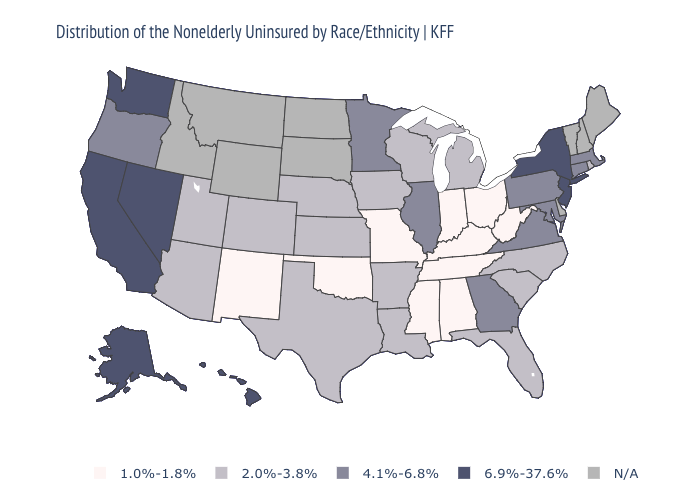Does Tennessee have the lowest value in the USA?
Write a very short answer. Yes. What is the highest value in the USA?
Quick response, please. 6.9%-37.6%. Among the states that border Nevada , which have the lowest value?
Answer briefly. Arizona, Utah. Which states have the lowest value in the USA?
Concise answer only. Alabama, Indiana, Kentucky, Mississippi, Missouri, New Mexico, Ohio, Oklahoma, Tennessee, West Virginia. What is the lowest value in the West?
Keep it brief. 1.0%-1.8%. What is the value of New Jersey?
Quick response, please. 6.9%-37.6%. Name the states that have a value in the range 4.1%-6.8%?
Quick response, please. Connecticut, Georgia, Illinois, Maryland, Massachusetts, Minnesota, Oregon, Pennsylvania, Virginia. What is the lowest value in the West?
Keep it brief. 1.0%-1.8%. Does the map have missing data?
Short answer required. Yes. What is the lowest value in the USA?
Quick response, please. 1.0%-1.8%. What is the highest value in the Northeast ?
Write a very short answer. 6.9%-37.6%. What is the value of Louisiana?
Concise answer only. 2.0%-3.8%. How many symbols are there in the legend?
Quick response, please. 5. Which states hav the highest value in the MidWest?
Answer briefly. Illinois, Minnesota. What is the value of Alaska?
Write a very short answer. 6.9%-37.6%. 